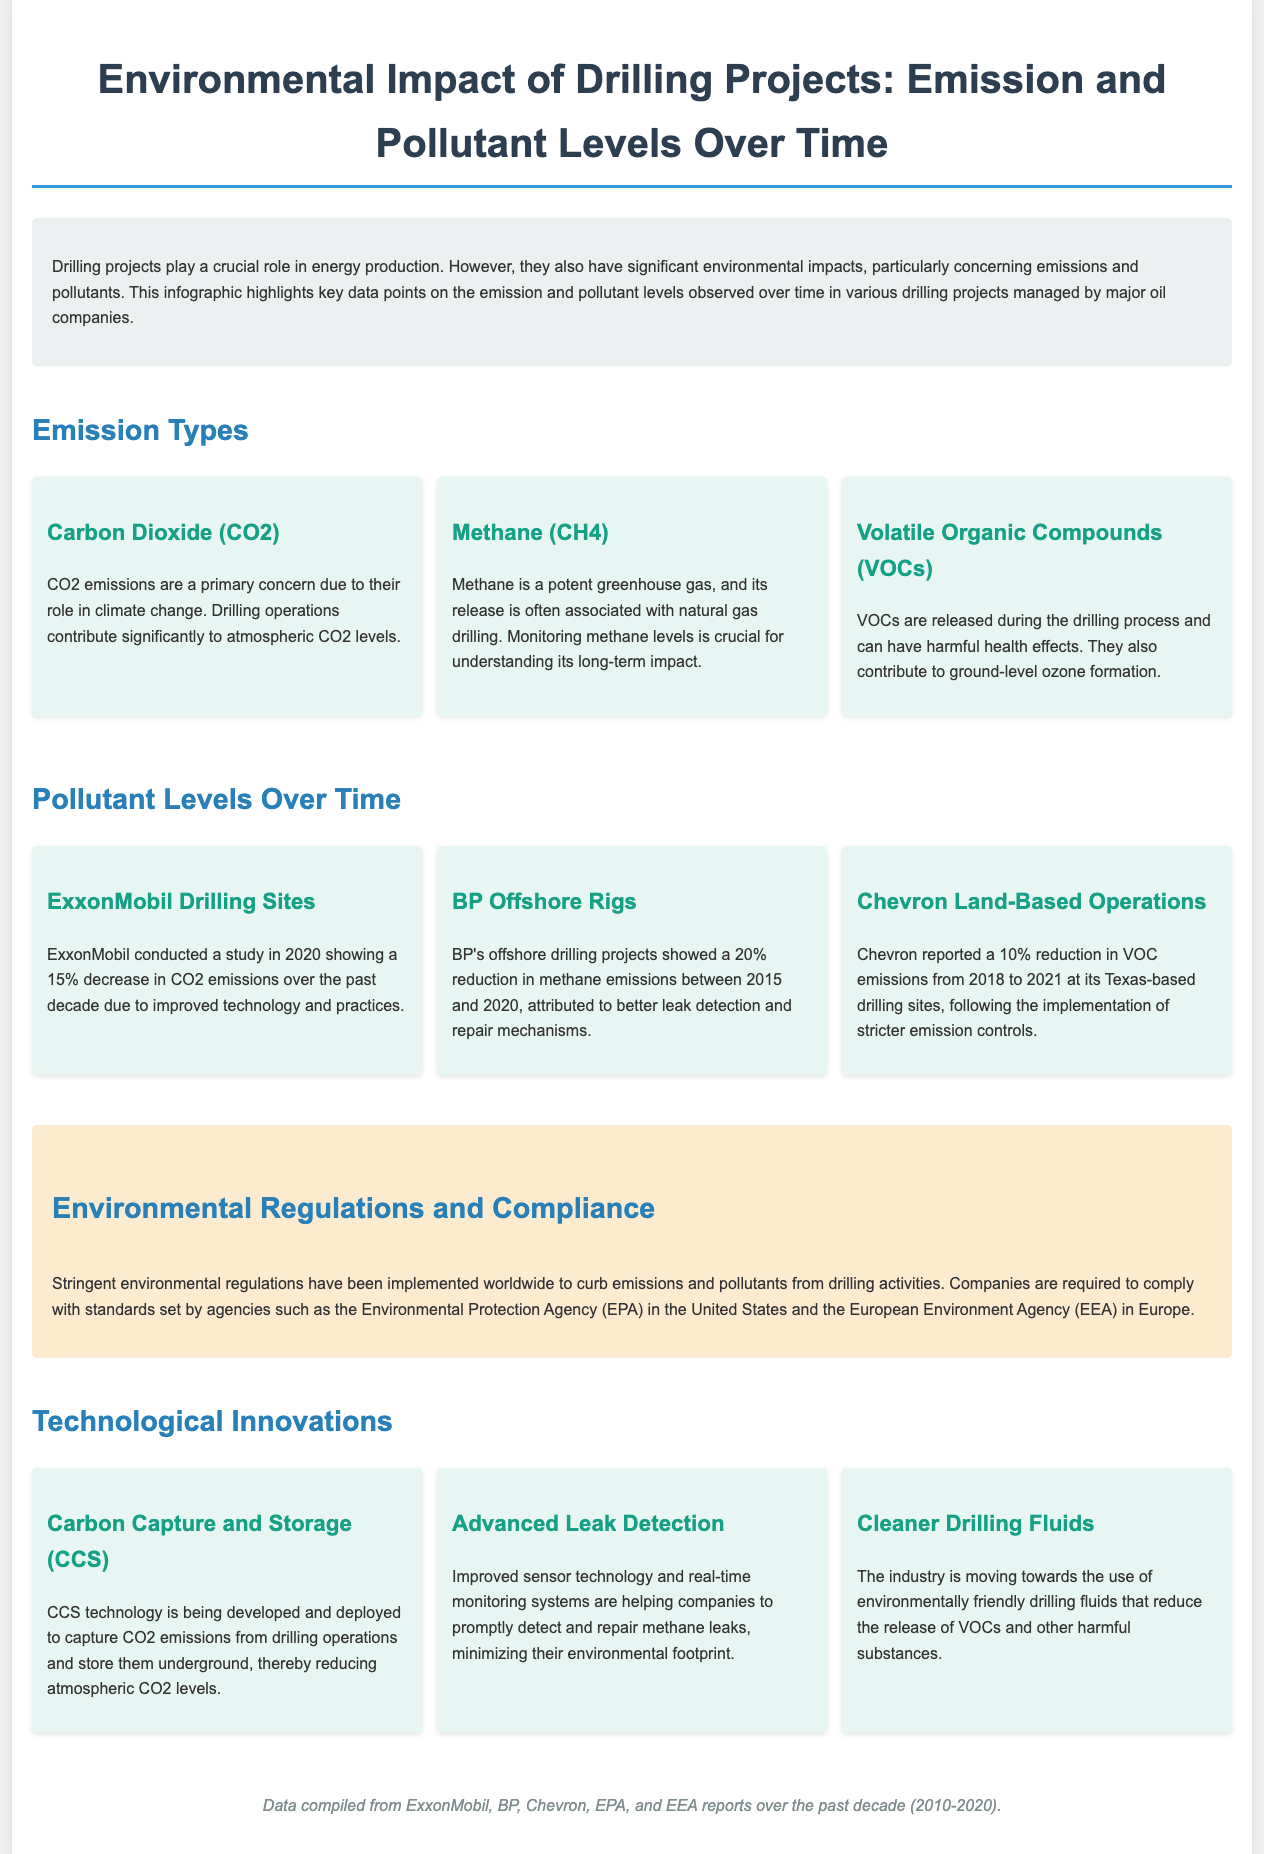What is the title of the infographic? The title of the infographic is stated prominently at the top of the document.
Answer: Environmental Impact of Drilling Projects: Emission and Pollutant Levels Over Time Which company reported a 15% decrease in CO2 emissions? This information is found in the case study section related to ExxonMobil's drilling sites.
Answer: ExxonMobil What reduction in methane emissions did BP achieve between 2015 and 2020? The document specifies the percentage reduction for BP's offshore rigs in the relevant case study.
Answer: 20% What are the three types of emissions mentioned? The document lists three specific types of emissions in the emission types section.
Answer: Carbon Dioxide, Methane, Volatile Organic Compounds What does CCS stand for? This abbreviation is defined in the section about technological innovations.
Answer: Carbon Capture and Storage Which technological innovation addresses methane leaks? This is mentioned under the innovations section, specifically focusing on how companies can minimize leak emissions.
Answer: Advanced Leak Detection What is the percentage reduction of VOC emissions reported by Chevron? The specific case study about Chevron provides this information regarding VOC emissions.
Answer: 10% What agency sets standards for emissions in the United States? This information is found in the regulations section, detailing compliance requirements for companies.
Answer: Environmental Protection Agency (EPA) What color is associated with the regulations section in the document? This information is derived from the visual design aspect of the document where sections are color-coded.
Answer: Light orange 